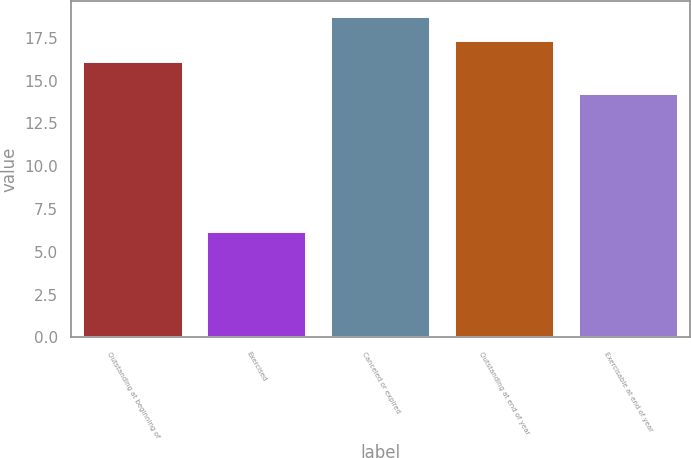<chart> <loc_0><loc_0><loc_500><loc_500><bar_chart><fcel>Outstanding at beginning of<fcel>Exercised<fcel>Canceled or expired<fcel>Outstanding at end of year<fcel>Exercisable at end of year<nl><fcel>16.07<fcel>6.14<fcel>18.72<fcel>17.33<fcel>14.24<nl></chart> 